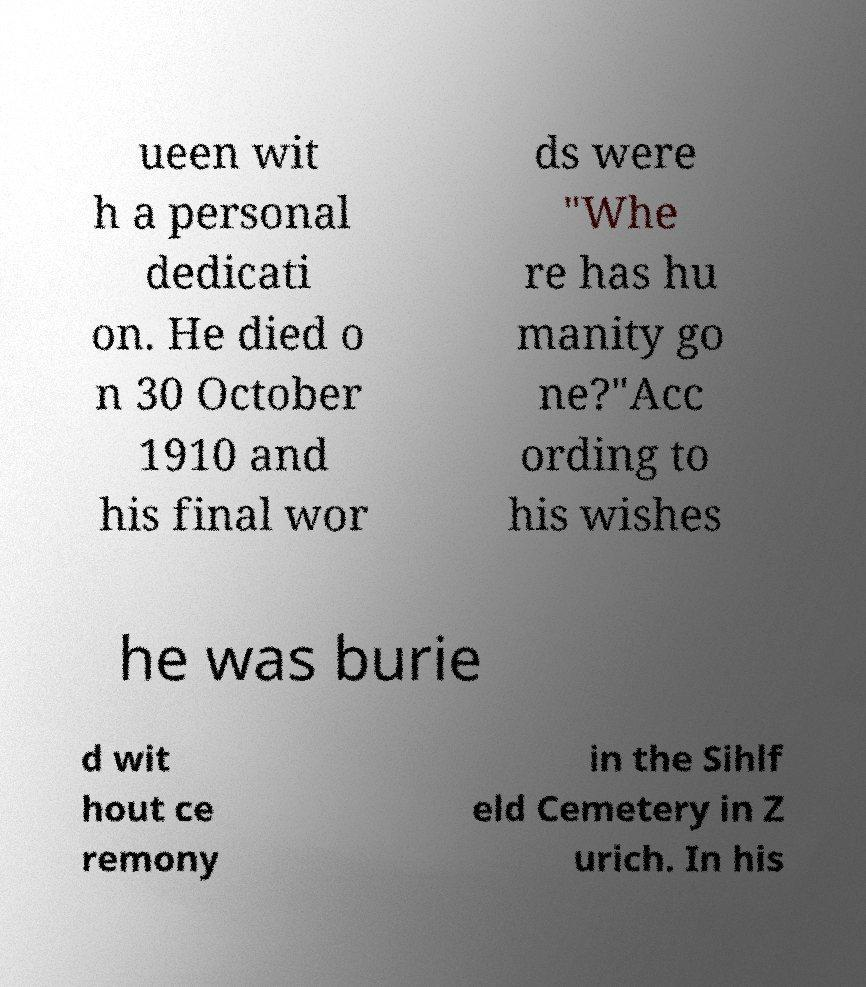I need the written content from this picture converted into text. Can you do that? ueen wit h a personal dedicati on. He died o n 30 October 1910 and his final wor ds were "Whe re has hu manity go ne?"Acc ording to his wishes he was burie d wit hout ce remony in the Sihlf eld Cemetery in Z urich. In his 